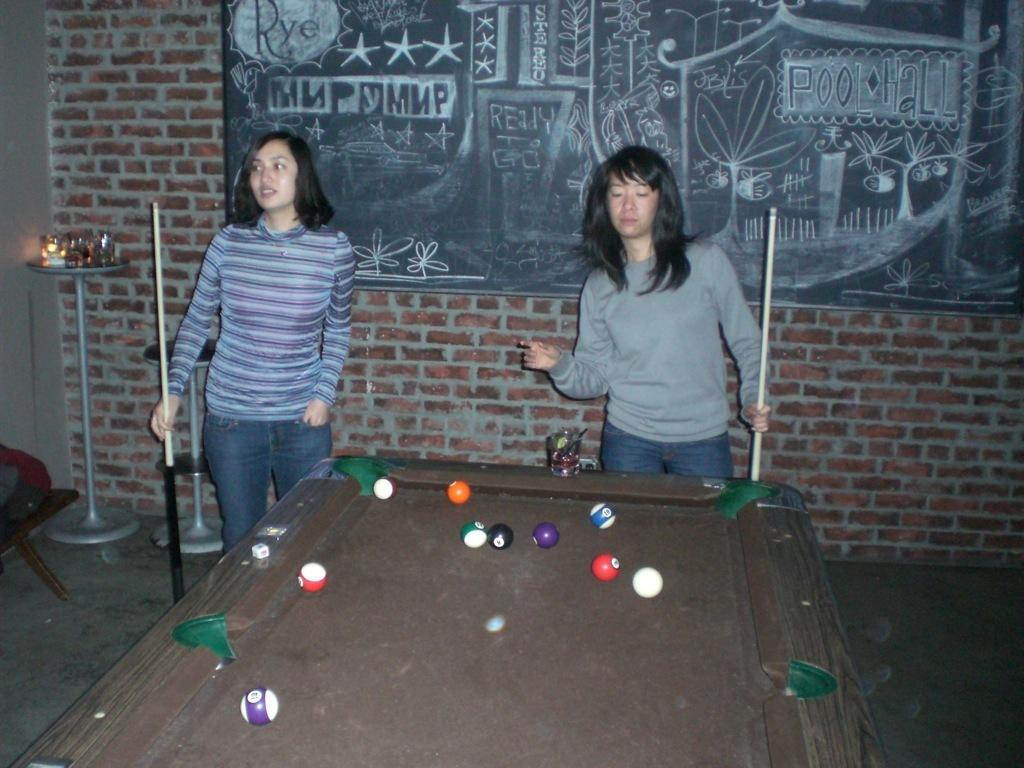How many people are in the image? There are two women in the image. What are the women doing in the image? The women are standing and playing pool. What are the women holding in their hands? The women are holding cues in their hands. What can be seen on the wall in the image? There is a black board on the wall. What type of wall is visible in the image? There is a brick wall visible in the image. What type of observation system is being used by the women in the image? There is no observation system present in the image; the women are playing pool. What kind of trip are the women taking in the image? There is no trip depicted in the image; the women are playing pool in a room with a brick wall and a black board. 